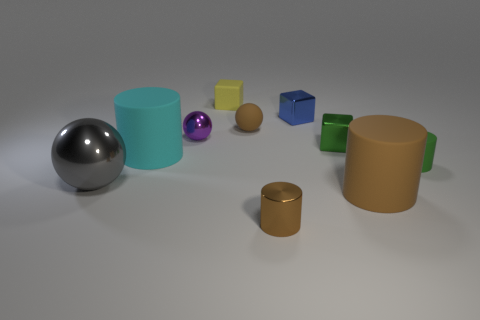Subtract all green rubber cylinders. How many cylinders are left? 3 Subtract all blue blocks. How many brown cylinders are left? 2 Subtract all green cylinders. How many cylinders are left? 3 Subtract 1 balls. How many balls are left? 2 Subtract all blocks. How many objects are left? 7 Subtract all green cylinders. Subtract all purple cubes. How many cylinders are left? 3 Subtract all small metal cubes. Subtract all tiny purple metallic objects. How many objects are left? 7 Add 1 green metal objects. How many green metal objects are left? 2 Add 1 metal balls. How many metal balls exist? 3 Subtract 0 yellow cylinders. How many objects are left? 10 